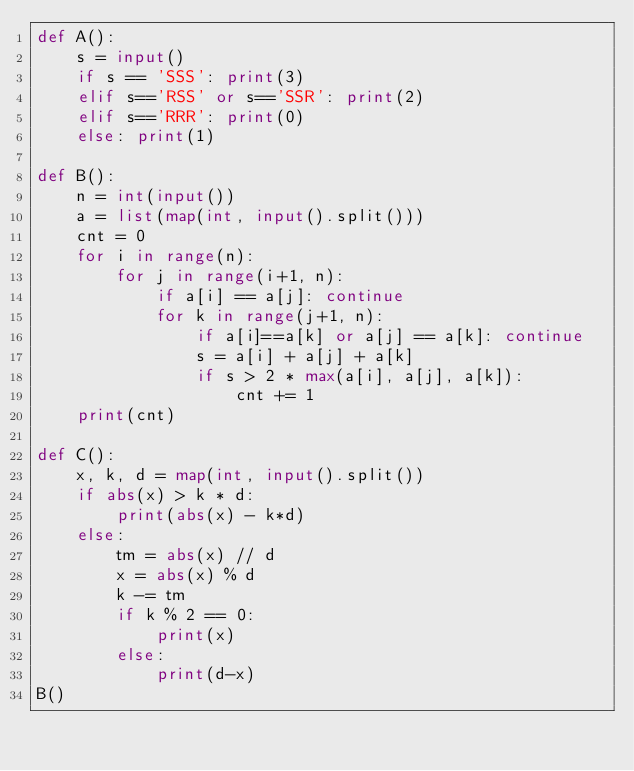Convert code to text. <code><loc_0><loc_0><loc_500><loc_500><_Python_>def A():
    s = input()
    if s == 'SSS': print(3)
    elif s=='RSS' or s=='SSR': print(2)
    elif s=='RRR': print(0)
    else: print(1)

def B():
    n = int(input())
    a = list(map(int, input().split()))
    cnt = 0
    for i in range(n):
        for j in range(i+1, n):
            if a[i] == a[j]: continue
            for k in range(j+1, n):
                if a[i]==a[k] or a[j] == a[k]: continue
                s = a[i] + a[j] + a[k]
                if s > 2 * max(a[i], a[j], a[k]):
                    cnt += 1
    print(cnt)

def C():
    x, k, d = map(int, input().split())
    if abs(x) > k * d:
        print(abs(x) - k*d)
    else:
        tm = abs(x) // d
        x = abs(x) % d
        k -= tm
        if k % 2 == 0:
            print(x)
        else:
            print(d-x)
B()
</code> 